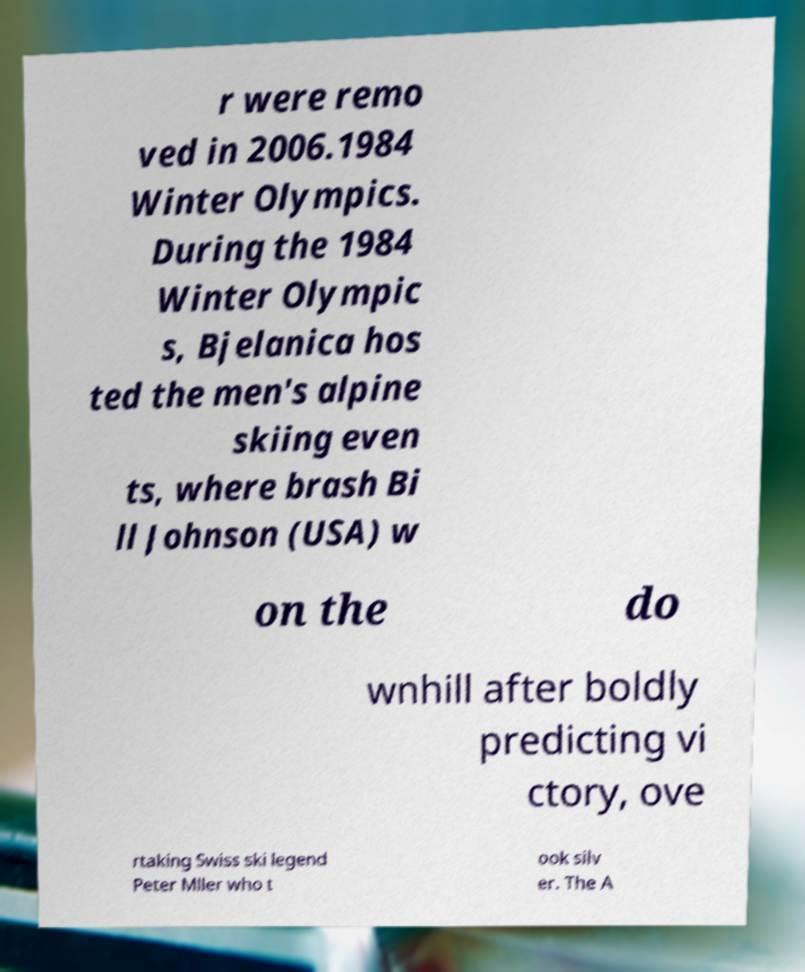Can you read and provide the text displayed in the image?This photo seems to have some interesting text. Can you extract and type it out for me? r were remo ved in 2006.1984 Winter Olympics. During the 1984 Winter Olympic s, Bjelanica hos ted the men's alpine skiing even ts, where brash Bi ll Johnson (USA) w on the do wnhill after boldly predicting vi ctory, ove rtaking Swiss ski legend Peter Mller who t ook silv er. The A 